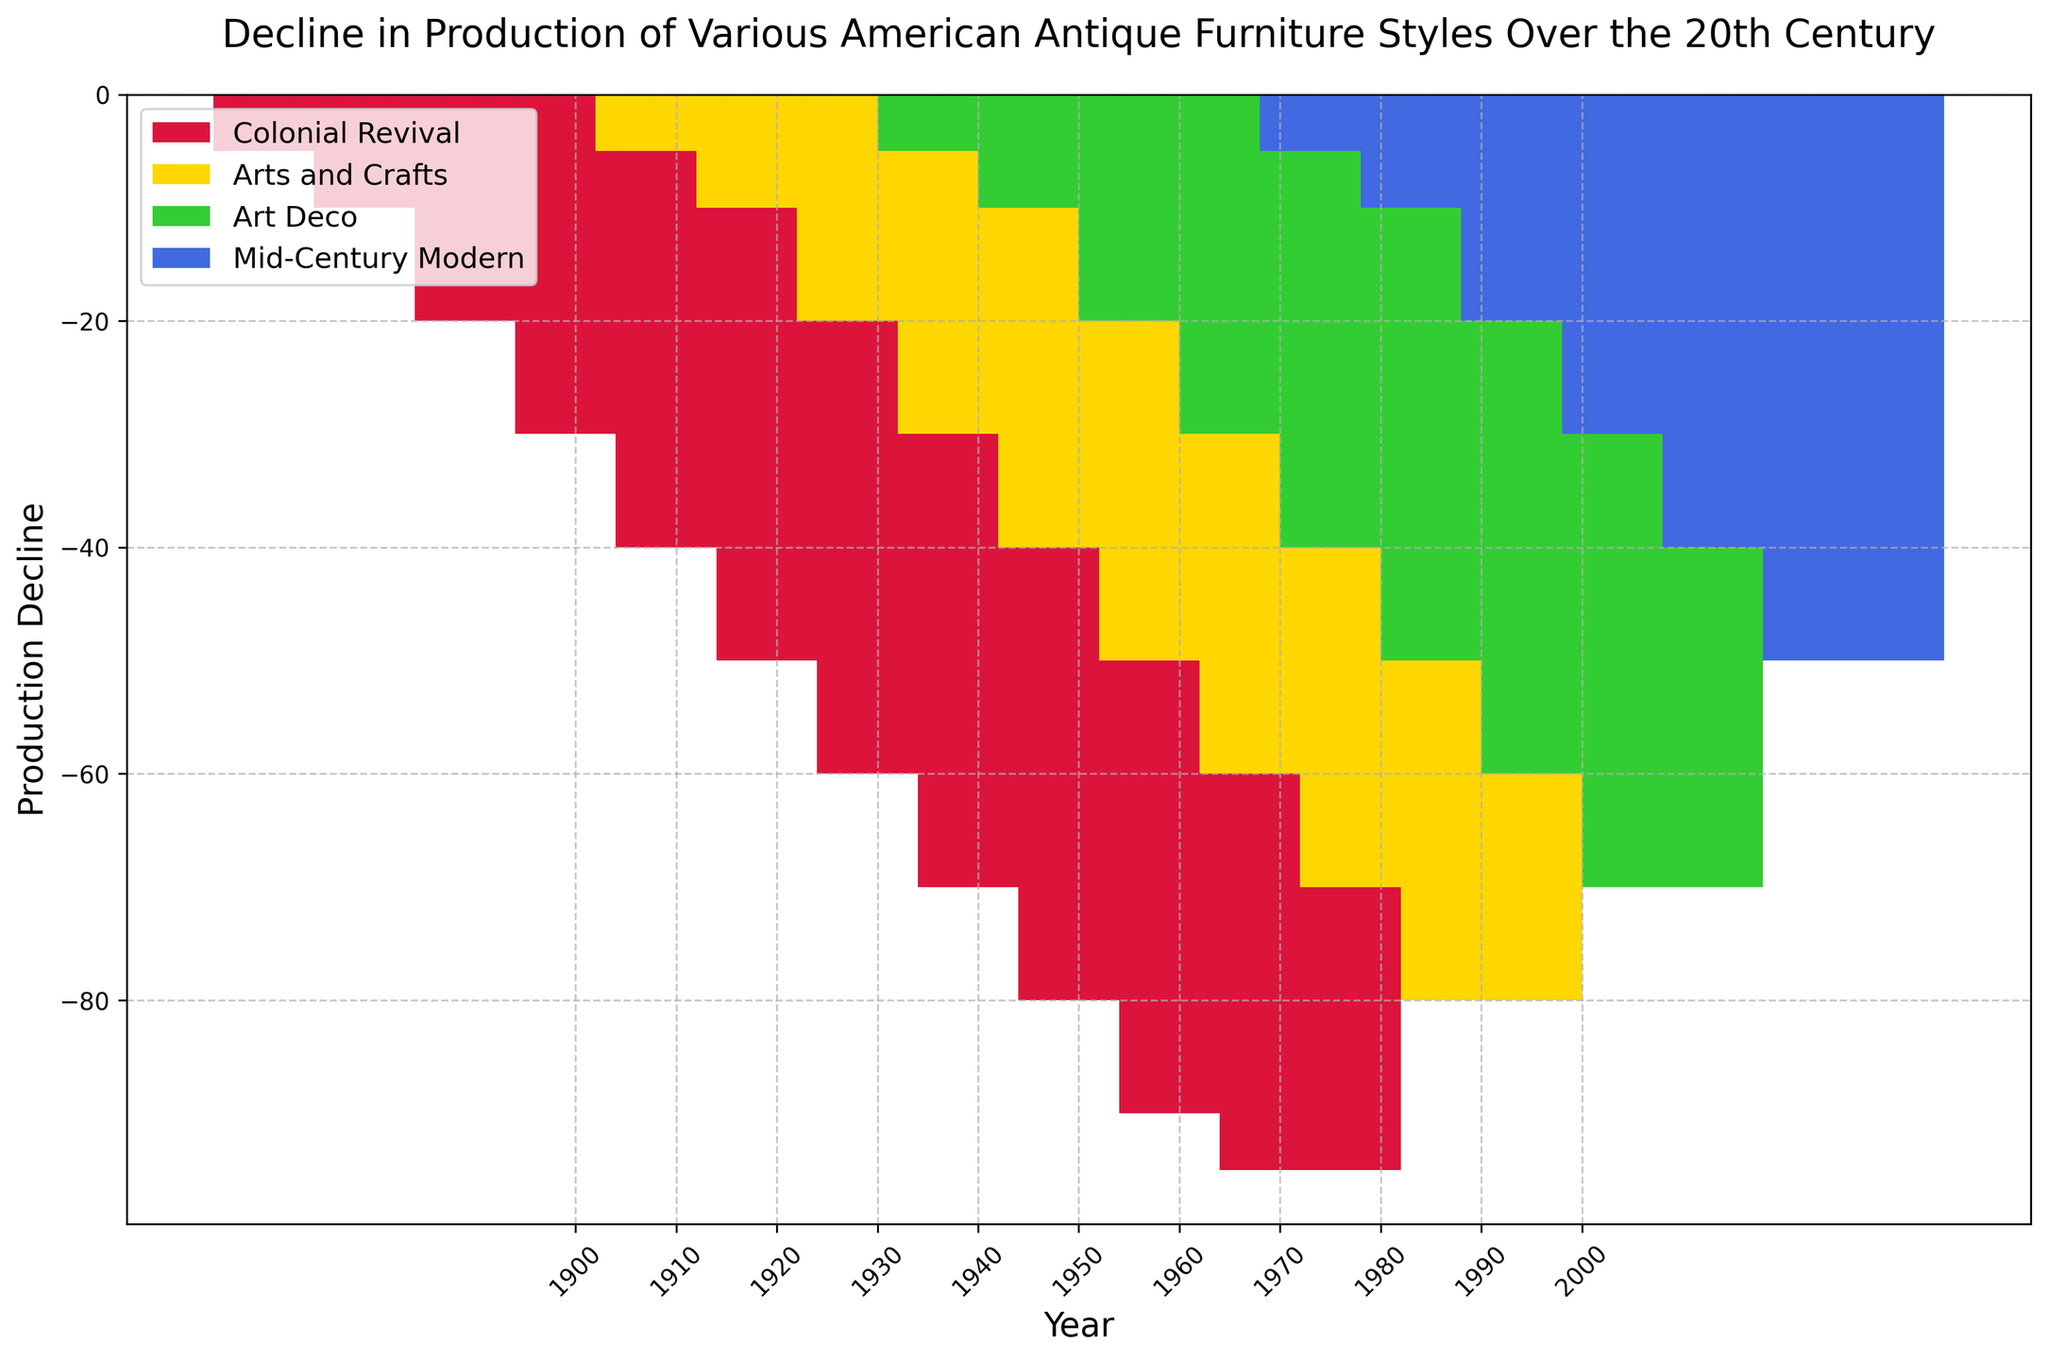What's the earliest year represented in the figure? The x-axis shows years, and the earliest year appears on the leftmost side. The earliest year is 1900.
Answer: 1900 Which furniture style experienced the greatest decline in production in the year 1930? By comparing the heights of the bars for each style in 1930, the Colonial Revival style has the lowest bar, indicating the steepest decline.
Answer: Colonial Revival In which decade did the Mid-Century Modern style first show a decline in production? Observing the bar for Mid-Century Modern across the years, the first negative value appears in 1950.
Answer: 1950 Compare the decline in the Colonial Revival style from 1900 to 2000. How much larger is the decline in 2000 than in 1900? In 1900, the decline is -5. In 2000, it is -95. The difference is -95 - (-5), which equals -90.
Answer: -90 What's the total decline in production for the Art Deco style over the entire century? Adding up the values for Art Deco from each decade: 0 (1900) + 0 (1910) + 0 (1920) + (-5) (1930) + (-10) (1940) + (-20) (1950) + (-30) (1960) + (-40) (1970) + (-50) (1980) + (-60) (1990) + (-70) (2000), the total is -285.
Answer: -285 Which decade saw the most substantial addition to the decline for the Arts and Crafts style? By comparing the differences between consecutive decades, the decline from 1990 (-70) to 2000 (-80) is the largest increase, showing a change of -10.
Answer: 1990 to 2000 What's the average decline of the Colonial Revival style over the 20th century? Summing the values from 1900 to 2000: -5, -10, -20, -30, -40, -50, -60, -70, -80, -90, -95, and dividing by the number of data points (11), the average is (-550 / 11 =) -50.
Answer: -50 What's the decline difference between Colonial Revival and Arts and Crafts in 1960? Colonial Revival in 1960 is -60 and Arts and Crafts is -40. The difference is -60 - (-40) = -20.
Answer: -20 Which furniture styles were in decline by the year 1940? Observing the bars for 1940, Colonial Revival, Arts and Crafts, and Art Deco all show negative values.
Answer: Colonial Revival, Arts and Crafts, Art Deco By what factor has the decline for Mid-Century Modern changed from 1950 to 2000? The decline in 1950 is -5, and in 2000 it is -50. The factor is -50 / -5 = 10.
Answer: 10 